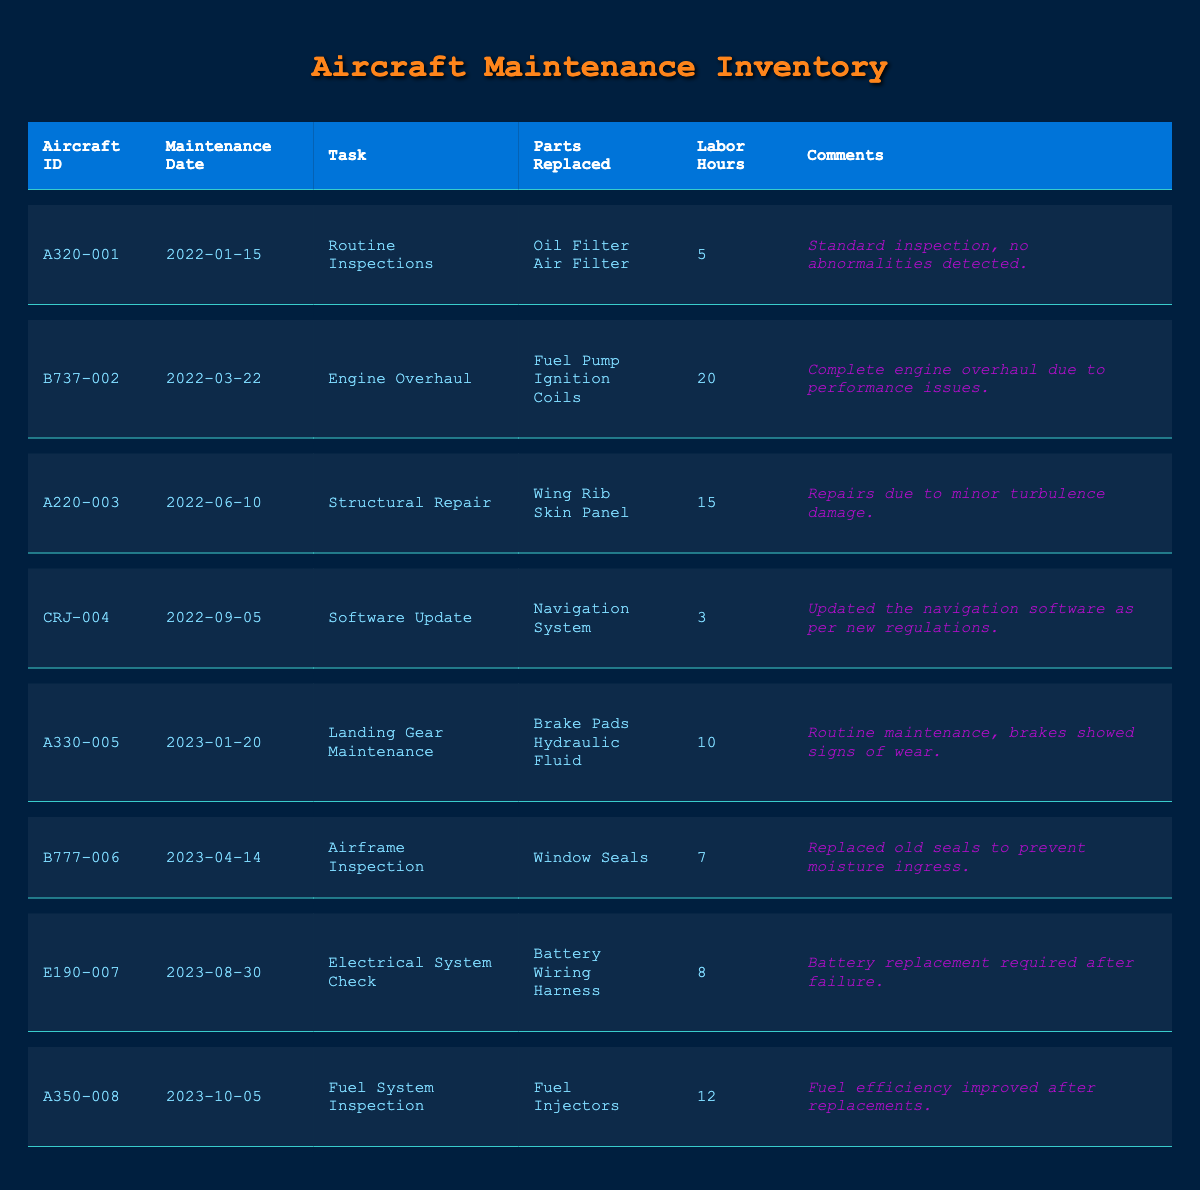What tasks were performed on A320-001? Referring to the table, the row for A320-001 indicates that the task performed was "Routine Inspections."
Answer: Routine Inspections How many labor hours were spent on the Engine Overhaul for B737-002? The table shows that for B737-002, the labor hours spent on the Engine Overhaul were 20.
Answer: 20 Did the A220-003 require any parts to be replaced during its maintenance? The entry for A220-003 lists "Wing Rib" and "Skin Panel" as parts replaced. Therefore, the answer is yes.
Answer: Yes What is the total number of labor hours across all maintenance tasks? To calculate the total, sum the labor hours shown: 5 + 20 + 15 + 3 + 10 + 7 + 8 + 12 = 80. Thus, the total number of labor hours is 80.
Answer: 80 Which aircraft had tasks related to inspections, and how many were performed? The table shows that A320-001 had "Routine Inspections," B777-006 had "Airframe Inspection," and A350-008 had "Fuel System Inspection." Therefore, three inspections were performed.
Answer: 3 What is the average labor hours for the tasks performed in 2023? The tasks in 2023 were for A330-005 (10), B777-006 (7), E190-007 (8), and A350-008 (12). Adding these gives 10 + 7 + 8 + 12 = 37. There are 4 tasks, so the average is 37 / 4 = 9.25.
Answer: 9.25 Was any aircraft maintained due to performance issues? According to the table, B737-002 underwent an "Engine Overhaul" due to performance issues, confirming that there was maintenance related to performance.
Answer: Yes Which task required the most labor hours and how many were involved? The Engine Overhaul for B737-002 had the most labor hours at 20.
Answer: 20 For which aircraft was the navigation system updated, and what were the labor hours for this task? The table shows that CRJ-004 had a "Software Update" for the navigation system, which took 3 labor hours.
Answer: CRJ-004, 3 labor hours 